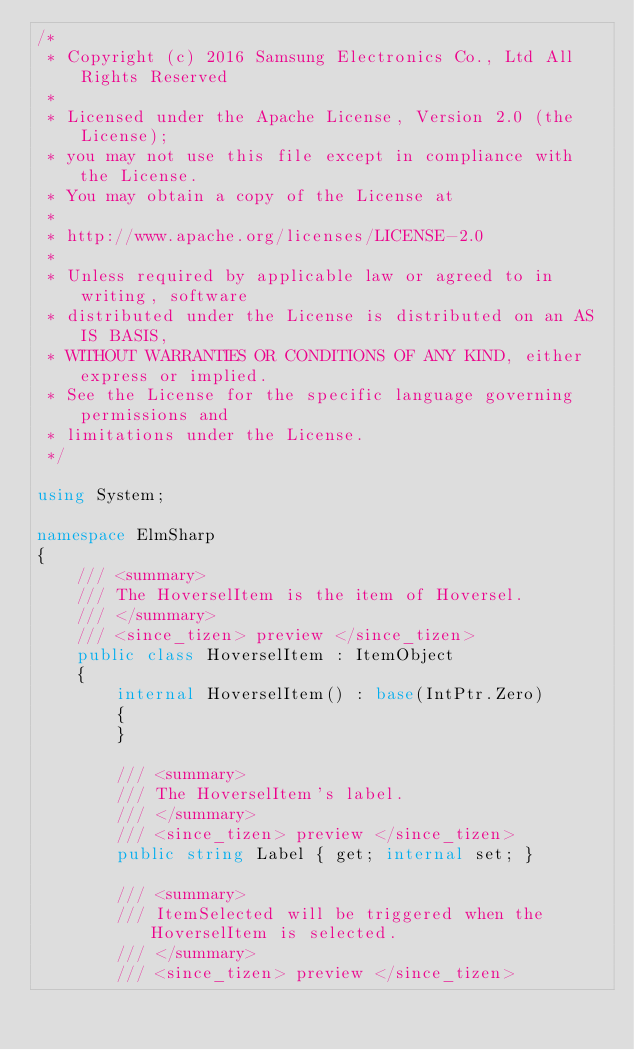<code> <loc_0><loc_0><loc_500><loc_500><_C#_>/*
 * Copyright (c) 2016 Samsung Electronics Co., Ltd All Rights Reserved
 *
 * Licensed under the Apache License, Version 2.0 (the License);
 * you may not use this file except in compliance with the License.
 * You may obtain a copy of the License at
 *
 * http://www.apache.org/licenses/LICENSE-2.0
 *
 * Unless required by applicable law or agreed to in writing, software
 * distributed under the License is distributed on an AS IS BASIS,
 * WITHOUT WARRANTIES OR CONDITIONS OF ANY KIND, either express or implied.
 * See the License for the specific language governing permissions and
 * limitations under the License.
 */

using System;

namespace ElmSharp
{
    /// <summary>
    /// The HoverselItem is the item of Hoversel.
    /// </summary>
    /// <since_tizen> preview </since_tizen>
    public class HoverselItem : ItemObject
    {
        internal HoverselItem() : base(IntPtr.Zero)
        {
        }

        /// <summary>
        /// The HoverselItem's label.
        /// </summary>
        /// <since_tizen> preview </since_tizen>
        public string Label { get; internal set; }

        /// <summary>
        /// ItemSelected will be triggered when the HoverselItem is selected.
        /// </summary>
        /// <since_tizen> preview </since_tizen></code> 